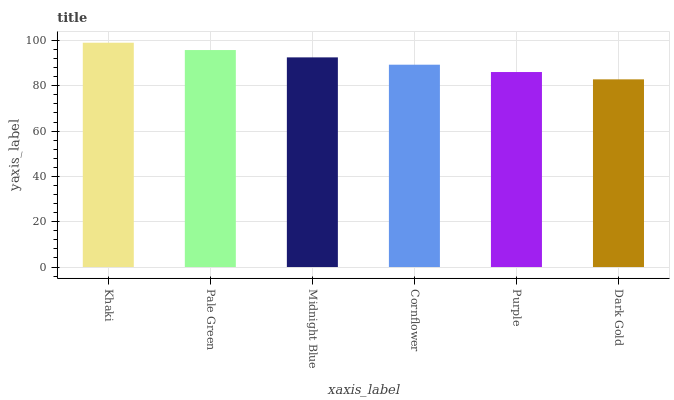Is Dark Gold the minimum?
Answer yes or no. Yes. Is Khaki the maximum?
Answer yes or no. Yes. Is Pale Green the minimum?
Answer yes or no. No. Is Pale Green the maximum?
Answer yes or no. No. Is Khaki greater than Pale Green?
Answer yes or no. Yes. Is Pale Green less than Khaki?
Answer yes or no. Yes. Is Pale Green greater than Khaki?
Answer yes or no. No. Is Khaki less than Pale Green?
Answer yes or no. No. Is Midnight Blue the high median?
Answer yes or no. Yes. Is Cornflower the low median?
Answer yes or no. Yes. Is Khaki the high median?
Answer yes or no. No. Is Pale Green the low median?
Answer yes or no. No. 